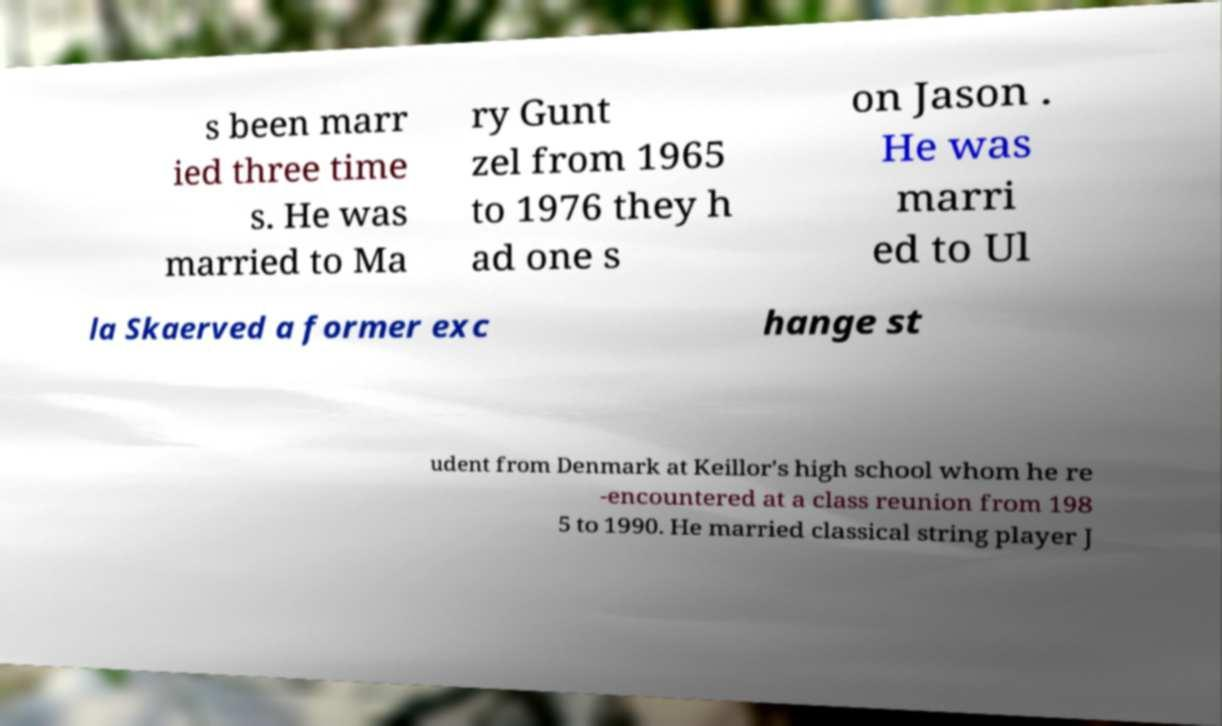I need the written content from this picture converted into text. Can you do that? s been marr ied three time s. He was married to Ma ry Gunt zel from 1965 to 1976 they h ad one s on Jason . He was marri ed to Ul la Skaerved a former exc hange st udent from Denmark at Keillor's high school whom he re -encountered at a class reunion from 198 5 to 1990. He married classical string player J 